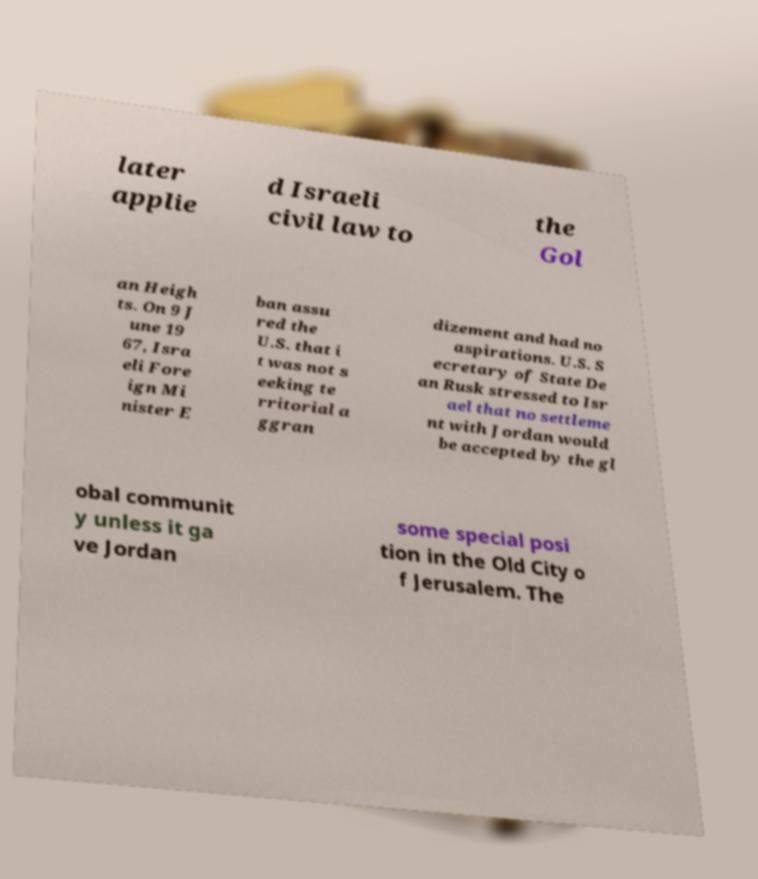Could you assist in decoding the text presented in this image and type it out clearly? later applie d Israeli civil law to the Gol an Heigh ts. On 9 J une 19 67, Isra eli Fore ign Mi nister E ban assu red the U.S. that i t was not s eeking te rritorial a ggran dizement and had no aspirations. U.S. S ecretary of State De an Rusk stressed to Isr ael that no settleme nt with Jordan would be accepted by the gl obal communit y unless it ga ve Jordan some special posi tion in the Old City o f Jerusalem. The 